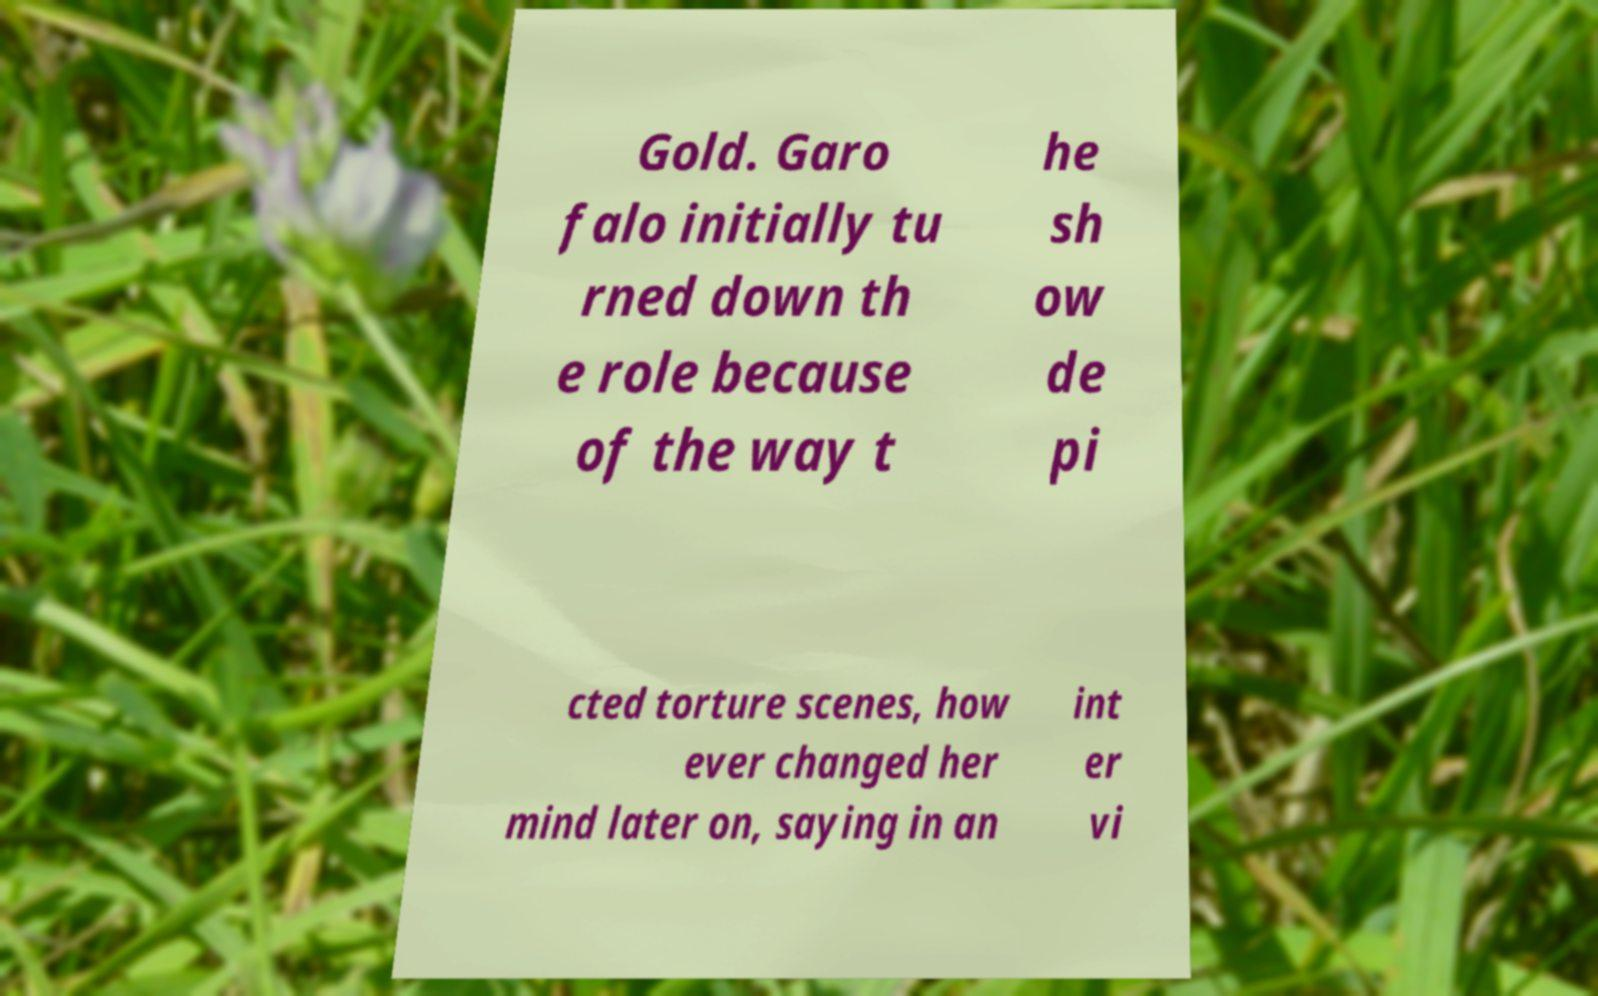What messages or text are displayed in this image? I need them in a readable, typed format. Gold. Garo falo initially tu rned down th e role because of the way t he sh ow de pi cted torture scenes, how ever changed her mind later on, saying in an int er vi 